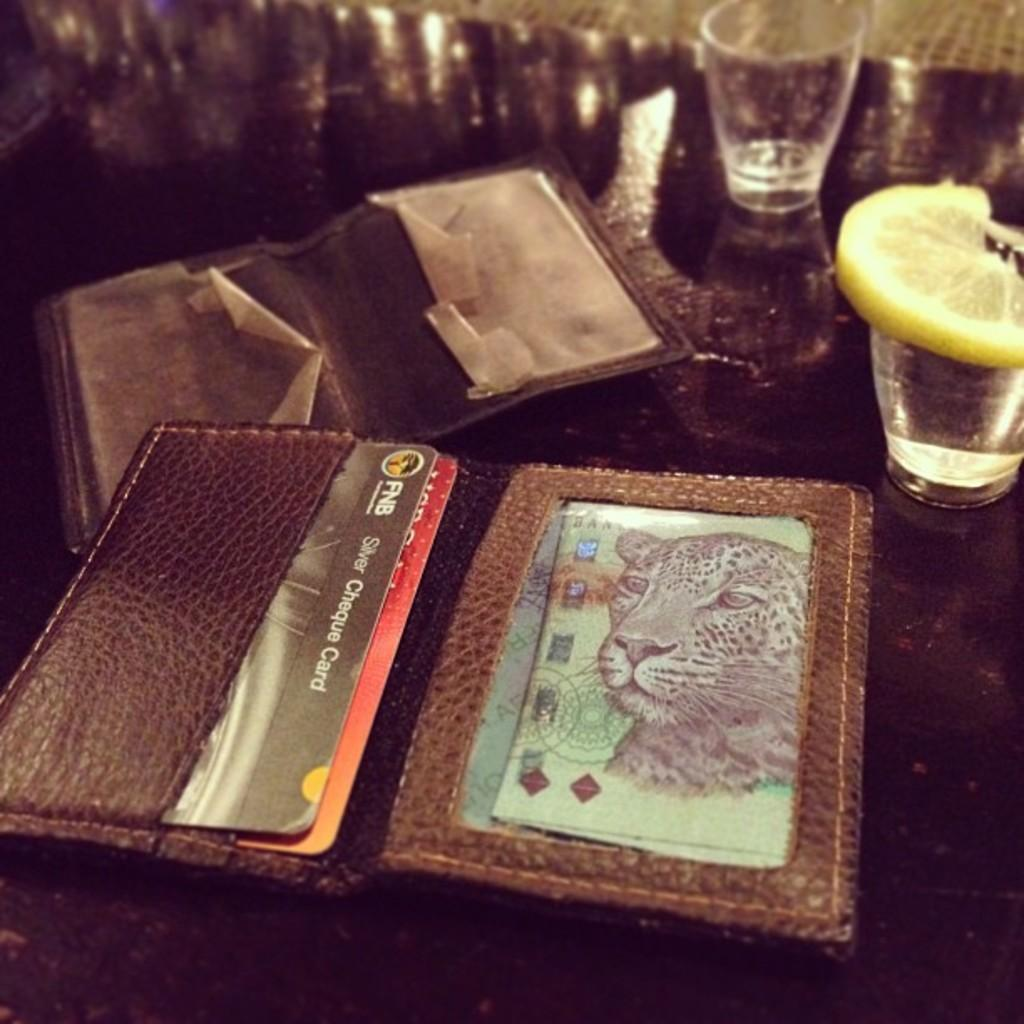<image>
Summarize the visual content of the image. A wallet sits open on a counter with a FNB Silver Cheque Card 